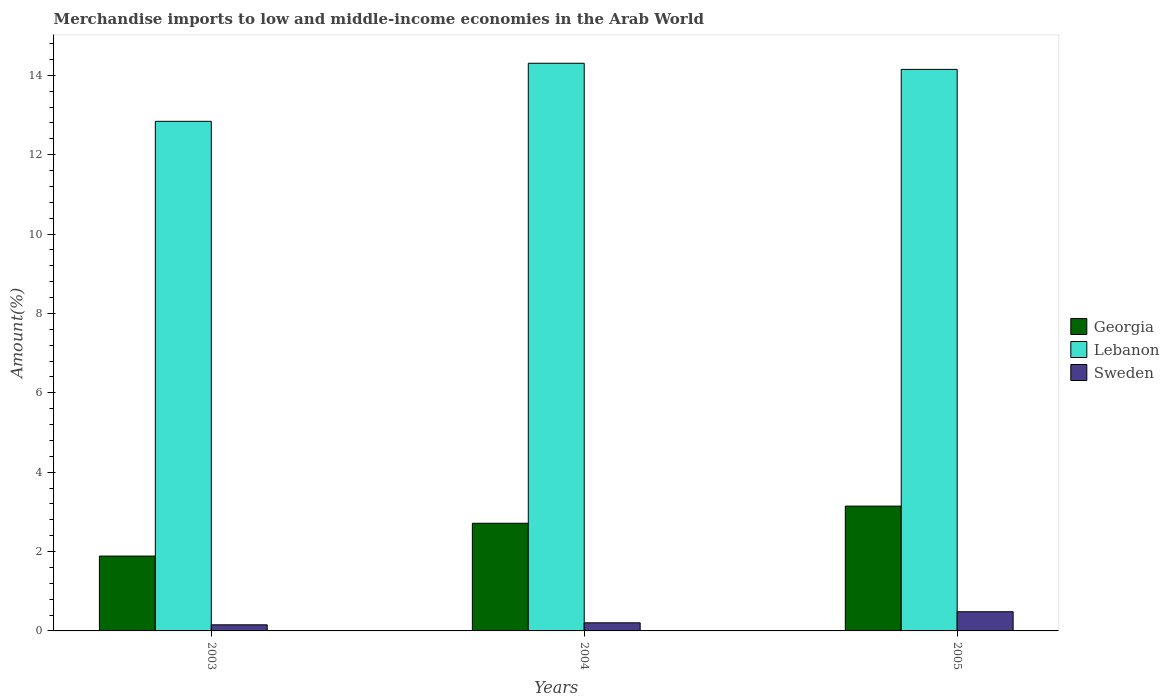How many groups of bars are there?
Your response must be concise. 3. Are the number of bars on each tick of the X-axis equal?
Keep it short and to the point. Yes. In how many cases, is the number of bars for a given year not equal to the number of legend labels?
Your response must be concise. 0. What is the percentage of amount earned from merchandise imports in Lebanon in 2004?
Your answer should be compact. 14.3. Across all years, what is the maximum percentage of amount earned from merchandise imports in Lebanon?
Offer a terse response. 14.3. Across all years, what is the minimum percentage of amount earned from merchandise imports in Lebanon?
Ensure brevity in your answer.  12.84. What is the total percentage of amount earned from merchandise imports in Lebanon in the graph?
Offer a terse response. 41.3. What is the difference between the percentage of amount earned from merchandise imports in Georgia in 2003 and that in 2004?
Offer a very short reply. -0.83. What is the difference between the percentage of amount earned from merchandise imports in Lebanon in 2005 and the percentage of amount earned from merchandise imports in Sweden in 2004?
Your answer should be very brief. 13.95. What is the average percentage of amount earned from merchandise imports in Lebanon per year?
Provide a short and direct response. 13.77. In the year 2004, what is the difference between the percentage of amount earned from merchandise imports in Sweden and percentage of amount earned from merchandise imports in Lebanon?
Your answer should be compact. -14.1. In how many years, is the percentage of amount earned from merchandise imports in Sweden greater than 0.8 %?
Your response must be concise. 0. What is the ratio of the percentage of amount earned from merchandise imports in Georgia in 2003 to that in 2004?
Your answer should be compact. 0.7. Is the percentage of amount earned from merchandise imports in Georgia in 2003 less than that in 2004?
Offer a terse response. Yes. Is the difference between the percentage of amount earned from merchandise imports in Sweden in 2003 and 2005 greater than the difference between the percentage of amount earned from merchandise imports in Lebanon in 2003 and 2005?
Provide a succinct answer. Yes. What is the difference between the highest and the second highest percentage of amount earned from merchandise imports in Georgia?
Offer a terse response. 0.43. What is the difference between the highest and the lowest percentage of amount earned from merchandise imports in Lebanon?
Make the answer very short. 1.46. Is the sum of the percentage of amount earned from merchandise imports in Lebanon in 2003 and 2005 greater than the maximum percentage of amount earned from merchandise imports in Sweden across all years?
Offer a terse response. Yes. What does the 2nd bar from the right in 2004 represents?
Keep it short and to the point. Lebanon. Is it the case that in every year, the sum of the percentage of amount earned from merchandise imports in Georgia and percentage of amount earned from merchandise imports in Sweden is greater than the percentage of amount earned from merchandise imports in Lebanon?
Your answer should be very brief. No. How many years are there in the graph?
Ensure brevity in your answer.  3. Are the values on the major ticks of Y-axis written in scientific E-notation?
Your response must be concise. No. Does the graph contain any zero values?
Offer a terse response. No. How are the legend labels stacked?
Offer a very short reply. Vertical. What is the title of the graph?
Your answer should be very brief. Merchandise imports to low and middle-income economies in the Arab World. Does "Bulgaria" appear as one of the legend labels in the graph?
Ensure brevity in your answer.  No. What is the label or title of the Y-axis?
Ensure brevity in your answer.  Amount(%). What is the Amount(%) of Georgia in 2003?
Your answer should be very brief. 1.89. What is the Amount(%) of Lebanon in 2003?
Your response must be concise. 12.84. What is the Amount(%) in Sweden in 2003?
Your response must be concise. 0.15. What is the Amount(%) of Georgia in 2004?
Provide a short and direct response. 2.71. What is the Amount(%) of Lebanon in 2004?
Keep it short and to the point. 14.3. What is the Amount(%) of Sweden in 2004?
Ensure brevity in your answer.  0.2. What is the Amount(%) of Georgia in 2005?
Your response must be concise. 3.15. What is the Amount(%) in Lebanon in 2005?
Offer a terse response. 14.15. What is the Amount(%) in Sweden in 2005?
Your answer should be very brief. 0.48. Across all years, what is the maximum Amount(%) in Georgia?
Provide a succinct answer. 3.15. Across all years, what is the maximum Amount(%) of Lebanon?
Make the answer very short. 14.3. Across all years, what is the maximum Amount(%) in Sweden?
Provide a succinct answer. 0.48. Across all years, what is the minimum Amount(%) of Georgia?
Make the answer very short. 1.89. Across all years, what is the minimum Amount(%) of Lebanon?
Your answer should be compact. 12.84. Across all years, what is the minimum Amount(%) of Sweden?
Offer a terse response. 0.15. What is the total Amount(%) of Georgia in the graph?
Ensure brevity in your answer.  7.74. What is the total Amount(%) of Lebanon in the graph?
Give a very brief answer. 41.3. What is the total Amount(%) of Sweden in the graph?
Provide a succinct answer. 0.84. What is the difference between the Amount(%) of Georgia in 2003 and that in 2004?
Provide a short and direct response. -0.83. What is the difference between the Amount(%) of Lebanon in 2003 and that in 2004?
Give a very brief answer. -1.46. What is the difference between the Amount(%) of Sweden in 2003 and that in 2004?
Provide a succinct answer. -0.05. What is the difference between the Amount(%) of Georgia in 2003 and that in 2005?
Keep it short and to the point. -1.26. What is the difference between the Amount(%) of Lebanon in 2003 and that in 2005?
Your answer should be compact. -1.31. What is the difference between the Amount(%) in Sweden in 2003 and that in 2005?
Your answer should be compact. -0.33. What is the difference between the Amount(%) of Georgia in 2004 and that in 2005?
Offer a terse response. -0.43. What is the difference between the Amount(%) of Lebanon in 2004 and that in 2005?
Give a very brief answer. 0.15. What is the difference between the Amount(%) in Sweden in 2004 and that in 2005?
Provide a succinct answer. -0.28. What is the difference between the Amount(%) of Georgia in 2003 and the Amount(%) of Lebanon in 2004?
Give a very brief answer. -12.42. What is the difference between the Amount(%) in Georgia in 2003 and the Amount(%) in Sweden in 2004?
Offer a terse response. 1.68. What is the difference between the Amount(%) in Lebanon in 2003 and the Amount(%) in Sweden in 2004?
Give a very brief answer. 12.64. What is the difference between the Amount(%) in Georgia in 2003 and the Amount(%) in Lebanon in 2005?
Provide a succinct answer. -12.26. What is the difference between the Amount(%) in Georgia in 2003 and the Amount(%) in Sweden in 2005?
Provide a short and direct response. 1.4. What is the difference between the Amount(%) of Lebanon in 2003 and the Amount(%) of Sweden in 2005?
Keep it short and to the point. 12.36. What is the difference between the Amount(%) in Georgia in 2004 and the Amount(%) in Lebanon in 2005?
Give a very brief answer. -11.44. What is the difference between the Amount(%) in Georgia in 2004 and the Amount(%) in Sweden in 2005?
Provide a short and direct response. 2.23. What is the difference between the Amount(%) of Lebanon in 2004 and the Amount(%) of Sweden in 2005?
Your answer should be very brief. 13.82. What is the average Amount(%) in Georgia per year?
Keep it short and to the point. 2.58. What is the average Amount(%) of Lebanon per year?
Provide a short and direct response. 13.77. What is the average Amount(%) in Sweden per year?
Give a very brief answer. 0.28. In the year 2003, what is the difference between the Amount(%) in Georgia and Amount(%) in Lebanon?
Provide a short and direct response. -10.96. In the year 2003, what is the difference between the Amount(%) in Georgia and Amount(%) in Sweden?
Your response must be concise. 1.73. In the year 2003, what is the difference between the Amount(%) of Lebanon and Amount(%) of Sweden?
Offer a terse response. 12.69. In the year 2004, what is the difference between the Amount(%) in Georgia and Amount(%) in Lebanon?
Ensure brevity in your answer.  -11.59. In the year 2004, what is the difference between the Amount(%) in Georgia and Amount(%) in Sweden?
Keep it short and to the point. 2.51. In the year 2004, what is the difference between the Amount(%) in Lebanon and Amount(%) in Sweden?
Give a very brief answer. 14.1. In the year 2005, what is the difference between the Amount(%) of Georgia and Amount(%) of Lebanon?
Your answer should be very brief. -11. In the year 2005, what is the difference between the Amount(%) in Georgia and Amount(%) in Sweden?
Offer a very short reply. 2.66. In the year 2005, what is the difference between the Amount(%) of Lebanon and Amount(%) of Sweden?
Your answer should be compact. 13.67. What is the ratio of the Amount(%) of Georgia in 2003 to that in 2004?
Your response must be concise. 0.7. What is the ratio of the Amount(%) in Lebanon in 2003 to that in 2004?
Offer a terse response. 0.9. What is the ratio of the Amount(%) of Sweden in 2003 to that in 2004?
Ensure brevity in your answer.  0.75. What is the ratio of the Amount(%) of Georgia in 2003 to that in 2005?
Your answer should be very brief. 0.6. What is the ratio of the Amount(%) of Lebanon in 2003 to that in 2005?
Provide a succinct answer. 0.91. What is the ratio of the Amount(%) in Sweden in 2003 to that in 2005?
Keep it short and to the point. 0.32. What is the ratio of the Amount(%) of Georgia in 2004 to that in 2005?
Provide a succinct answer. 0.86. What is the ratio of the Amount(%) in Lebanon in 2004 to that in 2005?
Offer a terse response. 1.01. What is the ratio of the Amount(%) of Sweden in 2004 to that in 2005?
Make the answer very short. 0.42. What is the difference between the highest and the second highest Amount(%) in Georgia?
Provide a short and direct response. 0.43. What is the difference between the highest and the second highest Amount(%) in Lebanon?
Provide a short and direct response. 0.15. What is the difference between the highest and the second highest Amount(%) in Sweden?
Offer a very short reply. 0.28. What is the difference between the highest and the lowest Amount(%) in Georgia?
Give a very brief answer. 1.26. What is the difference between the highest and the lowest Amount(%) in Lebanon?
Offer a terse response. 1.46. What is the difference between the highest and the lowest Amount(%) in Sweden?
Provide a short and direct response. 0.33. 